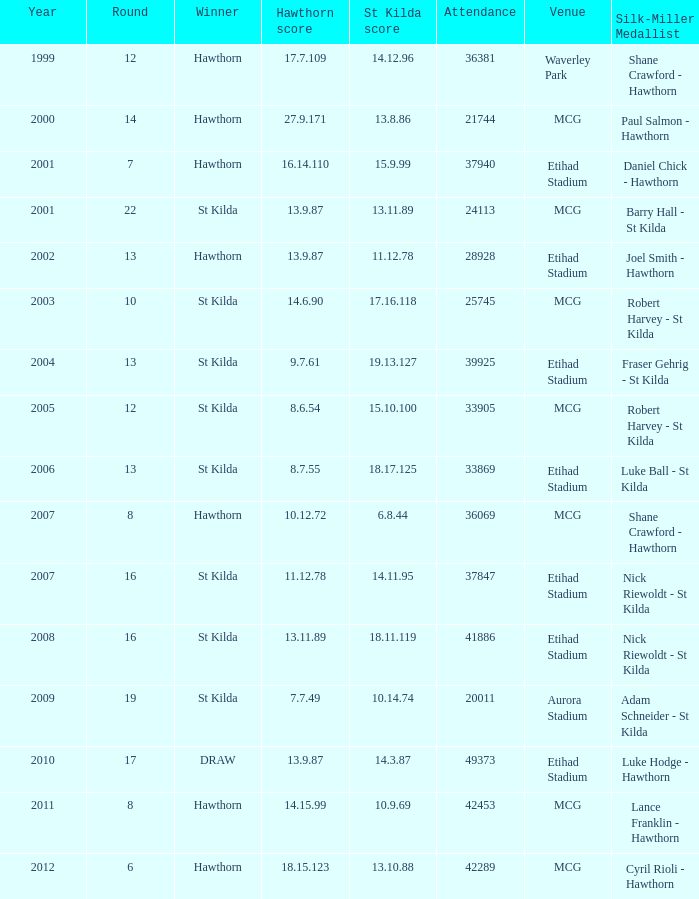How many winners have st kilda score at 14.11.95? 1.0. 